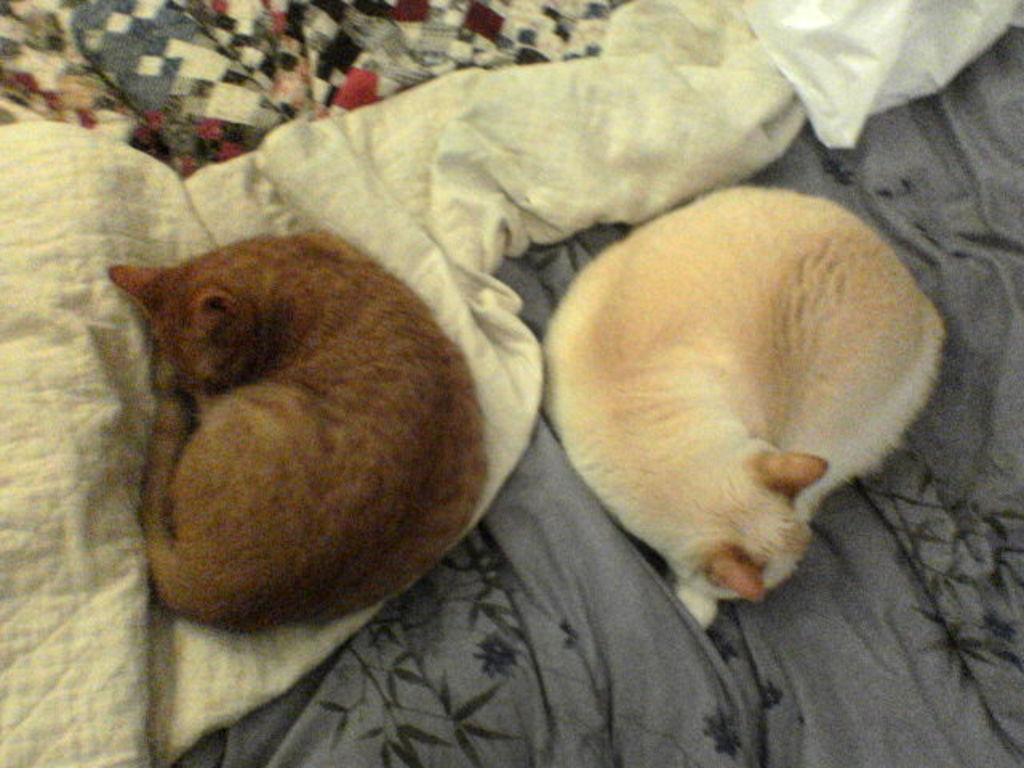How many cats are in the image? There are two cats in the image. What are the cats doing in the image? The cats are on clothes. What type of plough is being used by the cats in the image? There is no plough present in the image; it features two cats on clothes. What industry might the cats be involved in, as depicted in the image? The image does not depict any specific industry; it simply shows two cats on clothes. 